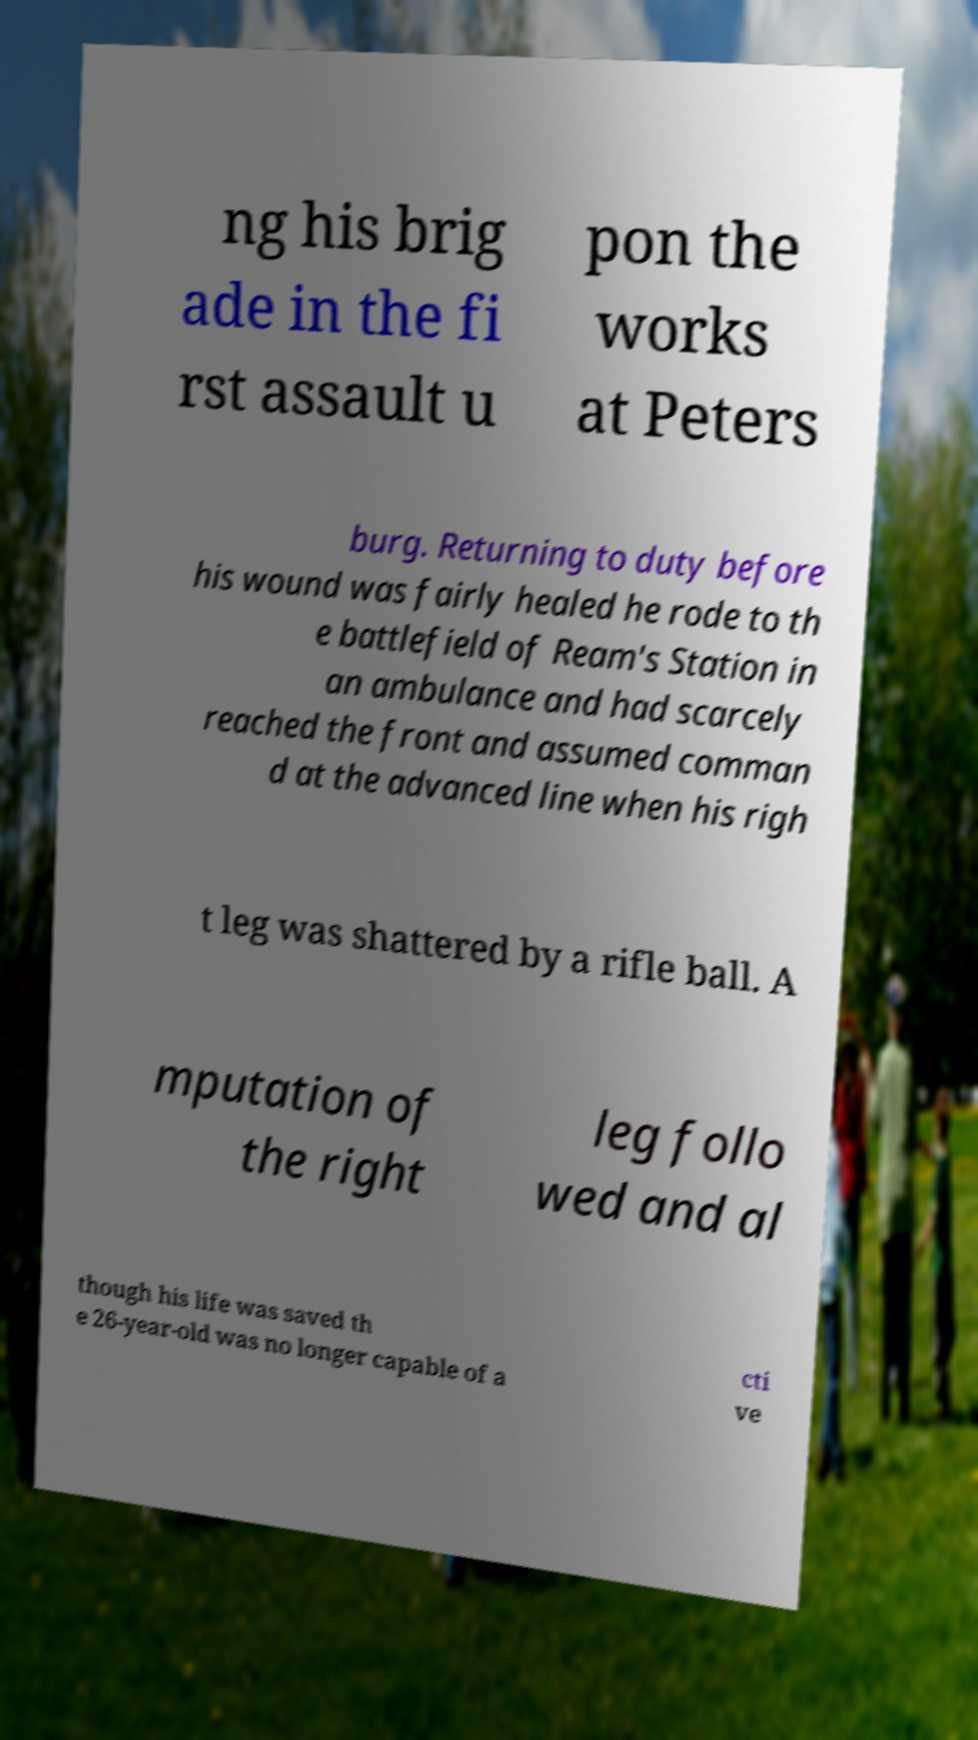Please read and relay the text visible in this image. What does it say? ng his brig ade in the fi rst assault u pon the works at Peters burg. Returning to duty before his wound was fairly healed he rode to th e battlefield of Ream's Station in an ambulance and had scarcely reached the front and assumed comman d at the advanced line when his righ t leg was shattered by a rifle ball. A mputation of the right leg follo wed and al though his life was saved th e 26-year-old was no longer capable of a cti ve 